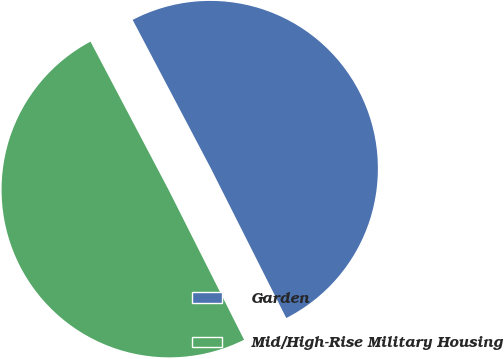<chart> <loc_0><loc_0><loc_500><loc_500><pie_chart><fcel>Garden<fcel>Mid/High-Rise Military Housing<nl><fcel>50.29%<fcel>49.71%<nl></chart> 